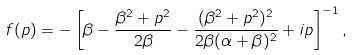<formula> <loc_0><loc_0><loc_500><loc_500>f ( p ) = - \left [ \beta - \frac { \beta ^ { 2 } + p ^ { 2 } } { 2 \beta } - \frac { ( \beta ^ { 2 } + p ^ { 2 } ) ^ { 2 } } { 2 \beta ( \alpha + \beta ) ^ { 2 } } + i p \right ] ^ { - 1 } ,</formula> 